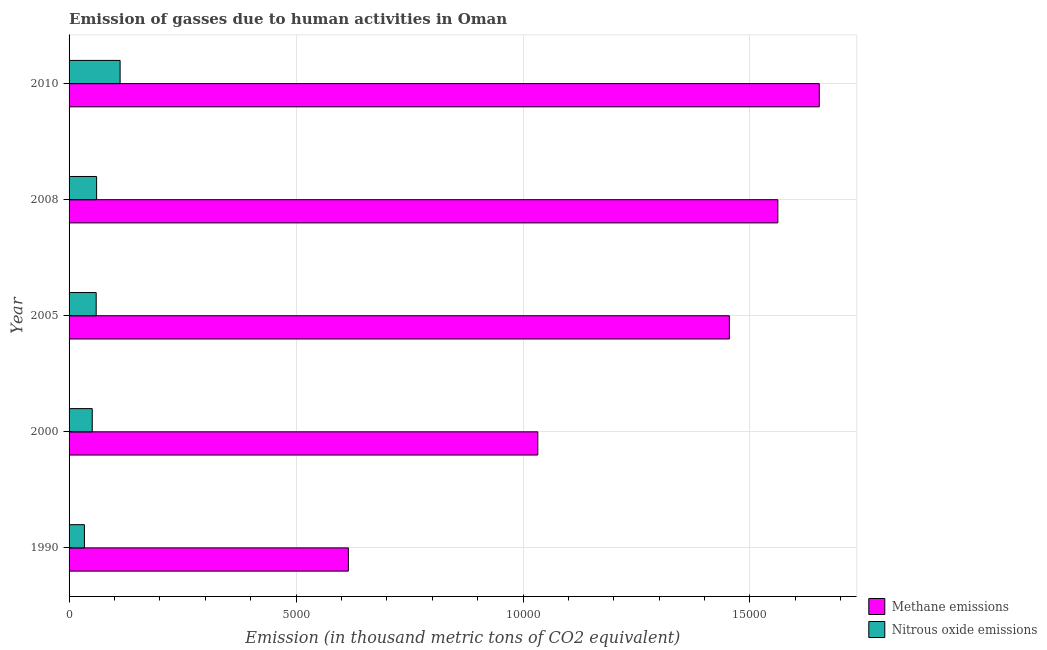How many different coloured bars are there?
Give a very brief answer. 2. How many groups of bars are there?
Make the answer very short. 5. Are the number of bars on each tick of the Y-axis equal?
Your response must be concise. Yes. How many bars are there on the 3rd tick from the top?
Your response must be concise. 2. How many bars are there on the 4th tick from the bottom?
Your answer should be compact. 2. In how many cases, is the number of bars for a given year not equal to the number of legend labels?
Make the answer very short. 0. What is the amount of nitrous oxide emissions in 1990?
Offer a terse response. 338.2. Across all years, what is the maximum amount of nitrous oxide emissions?
Your answer should be very brief. 1124.4. Across all years, what is the minimum amount of nitrous oxide emissions?
Your response must be concise. 338.2. In which year was the amount of nitrous oxide emissions maximum?
Keep it short and to the point. 2010. In which year was the amount of methane emissions minimum?
Your answer should be compact. 1990. What is the total amount of methane emissions in the graph?
Keep it short and to the point. 6.32e+04. What is the difference between the amount of methane emissions in 2008 and the amount of nitrous oxide emissions in 1990?
Your answer should be compact. 1.53e+04. What is the average amount of methane emissions per year?
Give a very brief answer. 1.26e+04. In the year 2000, what is the difference between the amount of nitrous oxide emissions and amount of methane emissions?
Your answer should be compact. -9815.7. What is the ratio of the amount of methane emissions in 2005 to that in 2010?
Give a very brief answer. 0.88. Is the difference between the amount of nitrous oxide emissions in 1990 and 2008 greater than the difference between the amount of methane emissions in 1990 and 2008?
Provide a short and direct response. Yes. What is the difference between the highest and the second highest amount of nitrous oxide emissions?
Your answer should be compact. 517.6. What is the difference between the highest and the lowest amount of nitrous oxide emissions?
Offer a terse response. 786.2. Is the sum of the amount of nitrous oxide emissions in 2000 and 2008 greater than the maximum amount of methane emissions across all years?
Offer a terse response. No. What does the 1st bar from the top in 2000 represents?
Provide a succinct answer. Nitrous oxide emissions. What does the 2nd bar from the bottom in 2008 represents?
Keep it short and to the point. Nitrous oxide emissions. Are the values on the major ticks of X-axis written in scientific E-notation?
Offer a very short reply. No. Does the graph contain any zero values?
Keep it short and to the point. No. How many legend labels are there?
Your answer should be compact. 2. How are the legend labels stacked?
Offer a terse response. Vertical. What is the title of the graph?
Your answer should be compact. Emission of gasses due to human activities in Oman. Does "Residents" appear as one of the legend labels in the graph?
Your answer should be compact. No. What is the label or title of the X-axis?
Provide a succinct answer. Emission (in thousand metric tons of CO2 equivalent). What is the label or title of the Y-axis?
Provide a short and direct response. Year. What is the Emission (in thousand metric tons of CO2 equivalent) of Methane emissions in 1990?
Provide a succinct answer. 6152.9. What is the Emission (in thousand metric tons of CO2 equivalent) of Nitrous oxide emissions in 1990?
Your response must be concise. 338.2. What is the Emission (in thousand metric tons of CO2 equivalent) in Methane emissions in 2000?
Your response must be concise. 1.03e+04. What is the Emission (in thousand metric tons of CO2 equivalent) in Nitrous oxide emissions in 2000?
Provide a short and direct response. 510.6. What is the Emission (in thousand metric tons of CO2 equivalent) of Methane emissions in 2005?
Provide a short and direct response. 1.45e+04. What is the Emission (in thousand metric tons of CO2 equivalent) in Nitrous oxide emissions in 2005?
Your answer should be compact. 597.3. What is the Emission (in thousand metric tons of CO2 equivalent) of Methane emissions in 2008?
Your response must be concise. 1.56e+04. What is the Emission (in thousand metric tons of CO2 equivalent) in Nitrous oxide emissions in 2008?
Keep it short and to the point. 606.8. What is the Emission (in thousand metric tons of CO2 equivalent) in Methane emissions in 2010?
Offer a very short reply. 1.65e+04. What is the Emission (in thousand metric tons of CO2 equivalent) of Nitrous oxide emissions in 2010?
Provide a short and direct response. 1124.4. Across all years, what is the maximum Emission (in thousand metric tons of CO2 equivalent) in Methane emissions?
Give a very brief answer. 1.65e+04. Across all years, what is the maximum Emission (in thousand metric tons of CO2 equivalent) in Nitrous oxide emissions?
Your answer should be very brief. 1124.4. Across all years, what is the minimum Emission (in thousand metric tons of CO2 equivalent) in Methane emissions?
Provide a succinct answer. 6152.9. Across all years, what is the minimum Emission (in thousand metric tons of CO2 equivalent) of Nitrous oxide emissions?
Your response must be concise. 338.2. What is the total Emission (in thousand metric tons of CO2 equivalent) of Methane emissions in the graph?
Give a very brief answer. 6.32e+04. What is the total Emission (in thousand metric tons of CO2 equivalent) of Nitrous oxide emissions in the graph?
Offer a terse response. 3177.3. What is the difference between the Emission (in thousand metric tons of CO2 equivalent) of Methane emissions in 1990 and that in 2000?
Your answer should be very brief. -4173.4. What is the difference between the Emission (in thousand metric tons of CO2 equivalent) in Nitrous oxide emissions in 1990 and that in 2000?
Keep it short and to the point. -172.4. What is the difference between the Emission (in thousand metric tons of CO2 equivalent) in Methane emissions in 1990 and that in 2005?
Your answer should be compact. -8393.2. What is the difference between the Emission (in thousand metric tons of CO2 equivalent) in Nitrous oxide emissions in 1990 and that in 2005?
Provide a succinct answer. -259.1. What is the difference between the Emission (in thousand metric tons of CO2 equivalent) in Methane emissions in 1990 and that in 2008?
Provide a succinct answer. -9461.4. What is the difference between the Emission (in thousand metric tons of CO2 equivalent) of Nitrous oxide emissions in 1990 and that in 2008?
Your answer should be compact. -268.6. What is the difference between the Emission (in thousand metric tons of CO2 equivalent) of Methane emissions in 1990 and that in 2010?
Your response must be concise. -1.04e+04. What is the difference between the Emission (in thousand metric tons of CO2 equivalent) of Nitrous oxide emissions in 1990 and that in 2010?
Provide a succinct answer. -786.2. What is the difference between the Emission (in thousand metric tons of CO2 equivalent) of Methane emissions in 2000 and that in 2005?
Offer a terse response. -4219.8. What is the difference between the Emission (in thousand metric tons of CO2 equivalent) of Nitrous oxide emissions in 2000 and that in 2005?
Keep it short and to the point. -86.7. What is the difference between the Emission (in thousand metric tons of CO2 equivalent) in Methane emissions in 2000 and that in 2008?
Give a very brief answer. -5288. What is the difference between the Emission (in thousand metric tons of CO2 equivalent) in Nitrous oxide emissions in 2000 and that in 2008?
Give a very brief answer. -96.2. What is the difference between the Emission (in thousand metric tons of CO2 equivalent) in Methane emissions in 2000 and that in 2010?
Give a very brief answer. -6200.9. What is the difference between the Emission (in thousand metric tons of CO2 equivalent) in Nitrous oxide emissions in 2000 and that in 2010?
Keep it short and to the point. -613.8. What is the difference between the Emission (in thousand metric tons of CO2 equivalent) in Methane emissions in 2005 and that in 2008?
Your answer should be very brief. -1068.2. What is the difference between the Emission (in thousand metric tons of CO2 equivalent) of Nitrous oxide emissions in 2005 and that in 2008?
Provide a short and direct response. -9.5. What is the difference between the Emission (in thousand metric tons of CO2 equivalent) in Methane emissions in 2005 and that in 2010?
Make the answer very short. -1981.1. What is the difference between the Emission (in thousand metric tons of CO2 equivalent) in Nitrous oxide emissions in 2005 and that in 2010?
Offer a very short reply. -527.1. What is the difference between the Emission (in thousand metric tons of CO2 equivalent) in Methane emissions in 2008 and that in 2010?
Offer a terse response. -912.9. What is the difference between the Emission (in thousand metric tons of CO2 equivalent) in Nitrous oxide emissions in 2008 and that in 2010?
Keep it short and to the point. -517.6. What is the difference between the Emission (in thousand metric tons of CO2 equivalent) in Methane emissions in 1990 and the Emission (in thousand metric tons of CO2 equivalent) in Nitrous oxide emissions in 2000?
Provide a succinct answer. 5642.3. What is the difference between the Emission (in thousand metric tons of CO2 equivalent) of Methane emissions in 1990 and the Emission (in thousand metric tons of CO2 equivalent) of Nitrous oxide emissions in 2005?
Your response must be concise. 5555.6. What is the difference between the Emission (in thousand metric tons of CO2 equivalent) of Methane emissions in 1990 and the Emission (in thousand metric tons of CO2 equivalent) of Nitrous oxide emissions in 2008?
Ensure brevity in your answer.  5546.1. What is the difference between the Emission (in thousand metric tons of CO2 equivalent) in Methane emissions in 1990 and the Emission (in thousand metric tons of CO2 equivalent) in Nitrous oxide emissions in 2010?
Your answer should be compact. 5028.5. What is the difference between the Emission (in thousand metric tons of CO2 equivalent) in Methane emissions in 2000 and the Emission (in thousand metric tons of CO2 equivalent) in Nitrous oxide emissions in 2005?
Provide a short and direct response. 9729. What is the difference between the Emission (in thousand metric tons of CO2 equivalent) in Methane emissions in 2000 and the Emission (in thousand metric tons of CO2 equivalent) in Nitrous oxide emissions in 2008?
Offer a terse response. 9719.5. What is the difference between the Emission (in thousand metric tons of CO2 equivalent) of Methane emissions in 2000 and the Emission (in thousand metric tons of CO2 equivalent) of Nitrous oxide emissions in 2010?
Your response must be concise. 9201.9. What is the difference between the Emission (in thousand metric tons of CO2 equivalent) of Methane emissions in 2005 and the Emission (in thousand metric tons of CO2 equivalent) of Nitrous oxide emissions in 2008?
Offer a terse response. 1.39e+04. What is the difference between the Emission (in thousand metric tons of CO2 equivalent) of Methane emissions in 2005 and the Emission (in thousand metric tons of CO2 equivalent) of Nitrous oxide emissions in 2010?
Provide a succinct answer. 1.34e+04. What is the difference between the Emission (in thousand metric tons of CO2 equivalent) of Methane emissions in 2008 and the Emission (in thousand metric tons of CO2 equivalent) of Nitrous oxide emissions in 2010?
Give a very brief answer. 1.45e+04. What is the average Emission (in thousand metric tons of CO2 equivalent) of Methane emissions per year?
Give a very brief answer. 1.26e+04. What is the average Emission (in thousand metric tons of CO2 equivalent) of Nitrous oxide emissions per year?
Your answer should be very brief. 635.46. In the year 1990, what is the difference between the Emission (in thousand metric tons of CO2 equivalent) in Methane emissions and Emission (in thousand metric tons of CO2 equivalent) in Nitrous oxide emissions?
Keep it short and to the point. 5814.7. In the year 2000, what is the difference between the Emission (in thousand metric tons of CO2 equivalent) in Methane emissions and Emission (in thousand metric tons of CO2 equivalent) in Nitrous oxide emissions?
Keep it short and to the point. 9815.7. In the year 2005, what is the difference between the Emission (in thousand metric tons of CO2 equivalent) of Methane emissions and Emission (in thousand metric tons of CO2 equivalent) of Nitrous oxide emissions?
Offer a terse response. 1.39e+04. In the year 2008, what is the difference between the Emission (in thousand metric tons of CO2 equivalent) in Methane emissions and Emission (in thousand metric tons of CO2 equivalent) in Nitrous oxide emissions?
Give a very brief answer. 1.50e+04. In the year 2010, what is the difference between the Emission (in thousand metric tons of CO2 equivalent) of Methane emissions and Emission (in thousand metric tons of CO2 equivalent) of Nitrous oxide emissions?
Keep it short and to the point. 1.54e+04. What is the ratio of the Emission (in thousand metric tons of CO2 equivalent) of Methane emissions in 1990 to that in 2000?
Your answer should be very brief. 0.6. What is the ratio of the Emission (in thousand metric tons of CO2 equivalent) in Nitrous oxide emissions in 1990 to that in 2000?
Offer a very short reply. 0.66. What is the ratio of the Emission (in thousand metric tons of CO2 equivalent) of Methane emissions in 1990 to that in 2005?
Your answer should be compact. 0.42. What is the ratio of the Emission (in thousand metric tons of CO2 equivalent) in Nitrous oxide emissions in 1990 to that in 2005?
Your response must be concise. 0.57. What is the ratio of the Emission (in thousand metric tons of CO2 equivalent) of Methane emissions in 1990 to that in 2008?
Give a very brief answer. 0.39. What is the ratio of the Emission (in thousand metric tons of CO2 equivalent) of Nitrous oxide emissions in 1990 to that in 2008?
Offer a terse response. 0.56. What is the ratio of the Emission (in thousand metric tons of CO2 equivalent) in Methane emissions in 1990 to that in 2010?
Give a very brief answer. 0.37. What is the ratio of the Emission (in thousand metric tons of CO2 equivalent) in Nitrous oxide emissions in 1990 to that in 2010?
Ensure brevity in your answer.  0.3. What is the ratio of the Emission (in thousand metric tons of CO2 equivalent) of Methane emissions in 2000 to that in 2005?
Your answer should be compact. 0.71. What is the ratio of the Emission (in thousand metric tons of CO2 equivalent) in Nitrous oxide emissions in 2000 to that in 2005?
Your response must be concise. 0.85. What is the ratio of the Emission (in thousand metric tons of CO2 equivalent) of Methane emissions in 2000 to that in 2008?
Your answer should be compact. 0.66. What is the ratio of the Emission (in thousand metric tons of CO2 equivalent) in Nitrous oxide emissions in 2000 to that in 2008?
Provide a short and direct response. 0.84. What is the ratio of the Emission (in thousand metric tons of CO2 equivalent) in Methane emissions in 2000 to that in 2010?
Your answer should be very brief. 0.62. What is the ratio of the Emission (in thousand metric tons of CO2 equivalent) of Nitrous oxide emissions in 2000 to that in 2010?
Your response must be concise. 0.45. What is the ratio of the Emission (in thousand metric tons of CO2 equivalent) in Methane emissions in 2005 to that in 2008?
Provide a short and direct response. 0.93. What is the ratio of the Emission (in thousand metric tons of CO2 equivalent) of Nitrous oxide emissions in 2005 to that in 2008?
Your answer should be compact. 0.98. What is the ratio of the Emission (in thousand metric tons of CO2 equivalent) in Methane emissions in 2005 to that in 2010?
Provide a short and direct response. 0.88. What is the ratio of the Emission (in thousand metric tons of CO2 equivalent) of Nitrous oxide emissions in 2005 to that in 2010?
Ensure brevity in your answer.  0.53. What is the ratio of the Emission (in thousand metric tons of CO2 equivalent) in Methane emissions in 2008 to that in 2010?
Provide a short and direct response. 0.94. What is the ratio of the Emission (in thousand metric tons of CO2 equivalent) in Nitrous oxide emissions in 2008 to that in 2010?
Provide a short and direct response. 0.54. What is the difference between the highest and the second highest Emission (in thousand metric tons of CO2 equivalent) of Methane emissions?
Ensure brevity in your answer.  912.9. What is the difference between the highest and the second highest Emission (in thousand metric tons of CO2 equivalent) in Nitrous oxide emissions?
Make the answer very short. 517.6. What is the difference between the highest and the lowest Emission (in thousand metric tons of CO2 equivalent) in Methane emissions?
Your answer should be compact. 1.04e+04. What is the difference between the highest and the lowest Emission (in thousand metric tons of CO2 equivalent) of Nitrous oxide emissions?
Keep it short and to the point. 786.2. 